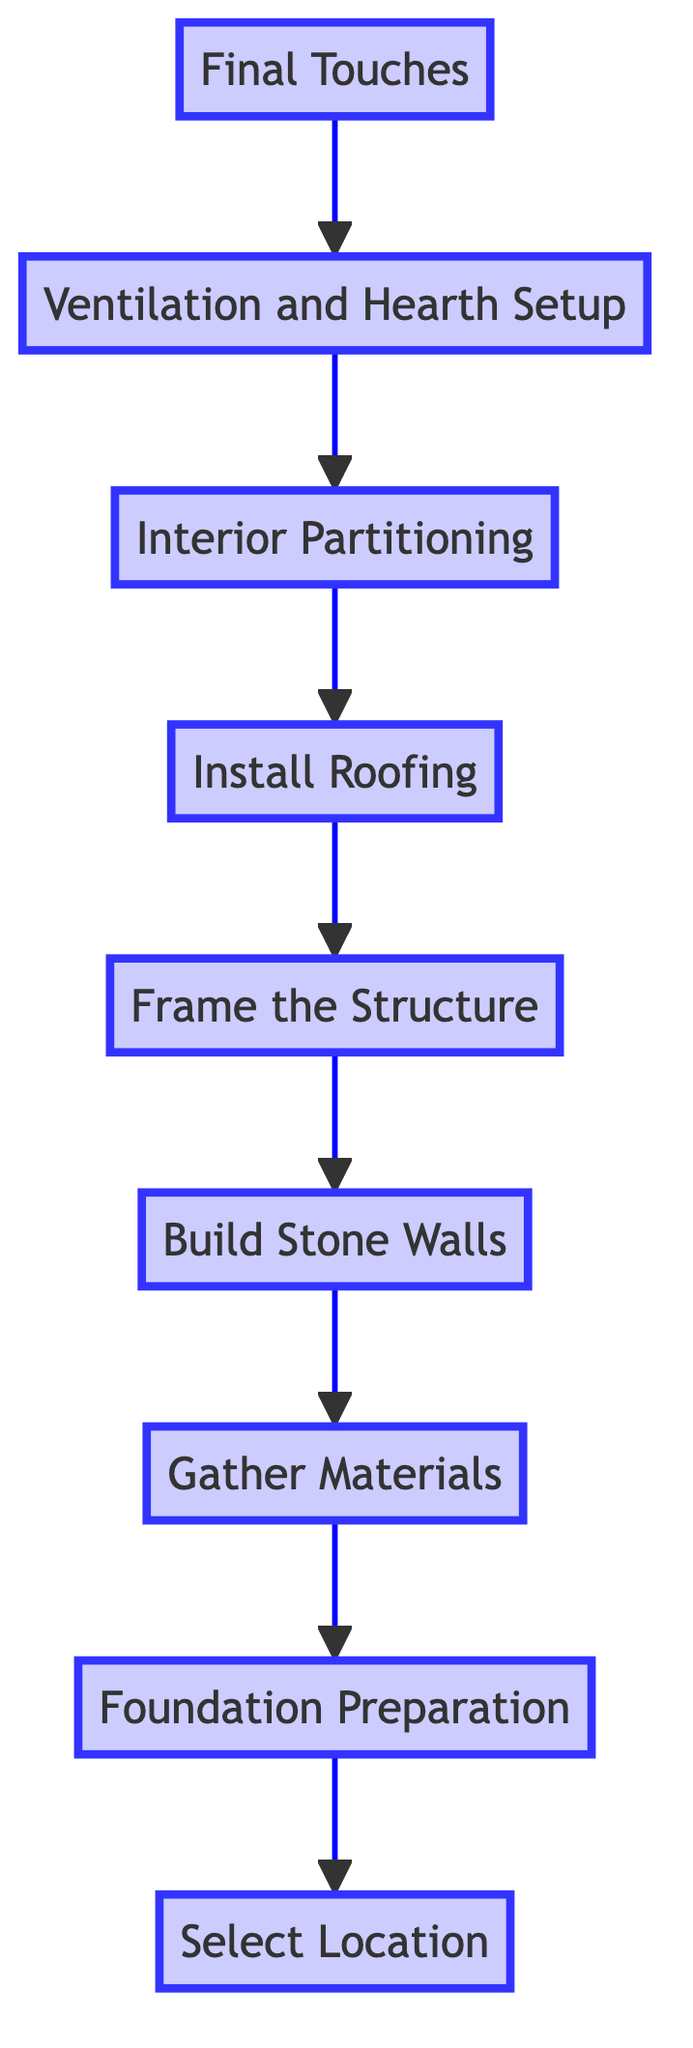What is the first step in constructing a traditional Sherpa dwelling? The diagram indicates that the first step is at the very bottom, labeled "Select Location." This is the initial action taken before any construction activities begin.
Answer: Select Location How many total steps are there in the diagram? By counting the number of unique labeled nodes shown in the diagram from bottom to top, we find that there are nine steps total.
Answer: Nine What follows after the "Final Touches"? According to the flow of the diagram, "Final Touches" is the last step, and there are no further steps that follow it.
Answer: None What does the structure built before the "Install Roofing"? The diagram shows that "Frame the Structure" comes directly before "Install Roofing." This means framing is necessary to support the roof.
Answer: Frame the Structure Which step involves preparing the materials needed for construction? The node labeled "Gather Materials" indicates the step where necessary materials are collected, prior to building the actual structure.
Answer: Gather Materials How does the "Interior Partitioning" relate to "Ventilation and Hearth Setup"? The flow indicates that "Interior Partitioning" happens after "Ventilation and Hearth Setup," meaning that once ventilation is established, the internal divisions can be made within the dwelling.
Answer: "Interior Partitioning" follows "Ventilation and Hearth Setup." What is the last construction element added to the dwelling according to the diagram? The "Final Touches" indicates that it is the concluding step in the construction process, which includes decorating and preparing the house for habitation.
Answer: Final Touches Which step is primarily concerned with weather preparedness? "Build Stone Walls" is notably focused on insulation against the cold, indicating its importance in relation to weather conditions.
Answer: Build Stone Walls Which step comes directly after "Gather Materials"? According to the diagram's flow, the next step after "Gather Materials" is "Build Stone Walls," which indicates a continuation of the construction process.
Answer: Build Stone Walls 